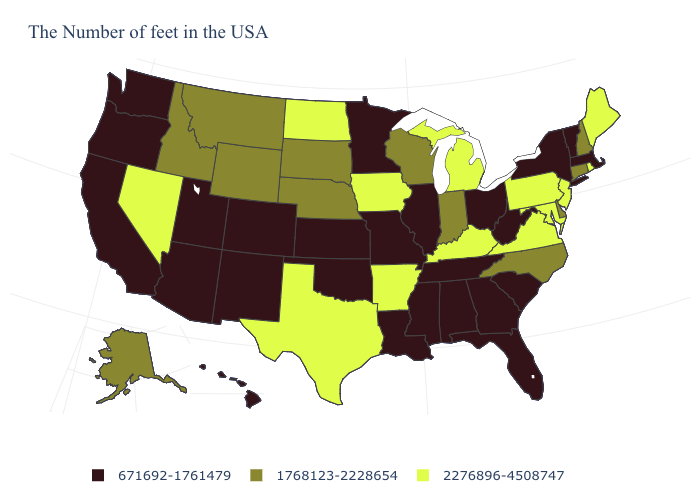What is the value of Arizona?
Keep it brief. 671692-1761479. What is the value of Nevada?
Be succinct. 2276896-4508747. Does the first symbol in the legend represent the smallest category?
Keep it brief. Yes. Does South Carolina have a higher value than Nebraska?
Concise answer only. No. Name the states that have a value in the range 671692-1761479?
Keep it brief. Massachusetts, Vermont, New York, South Carolina, West Virginia, Ohio, Florida, Georgia, Alabama, Tennessee, Illinois, Mississippi, Louisiana, Missouri, Minnesota, Kansas, Oklahoma, Colorado, New Mexico, Utah, Arizona, California, Washington, Oregon, Hawaii. Is the legend a continuous bar?
Answer briefly. No. What is the lowest value in states that border Texas?
Be succinct. 671692-1761479. What is the value of Texas?
Write a very short answer. 2276896-4508747. What is the highest value in the USA?
Keep it brief. 2276896-4508747. What is the highest value in the MidWest ?
Short answer required. 2276896-4508747. Name the states that have a value in the range 671692-1761479?
Answer briefly. Massachusetts, Vermont, New York, South Carolina, West Virginia, Ohio, Florida, Georgia, Alabama, Tennessee, Illinois, Mississippi, Louisiana, Missouri, Minnesota, Kansas, Oklahoma, Colorado, New Mexico, Utah, Arizona, California, Washington, Oregon, Hawaii. Name the states that have a value in the range 2276896-4508747?
Give a very brief answer. Maine, Rhode Island, New Jersey, Maryland, Pennsylvania, Virginia, Michigan, Kentucky, Arkansas, Iowa, Texas, North Dakota, Nevada. What is the value of Vermont?
Short answer required. 671692-1761479. Does North Carolina have the same value as Massachusetts?
Quick response, please. No. 